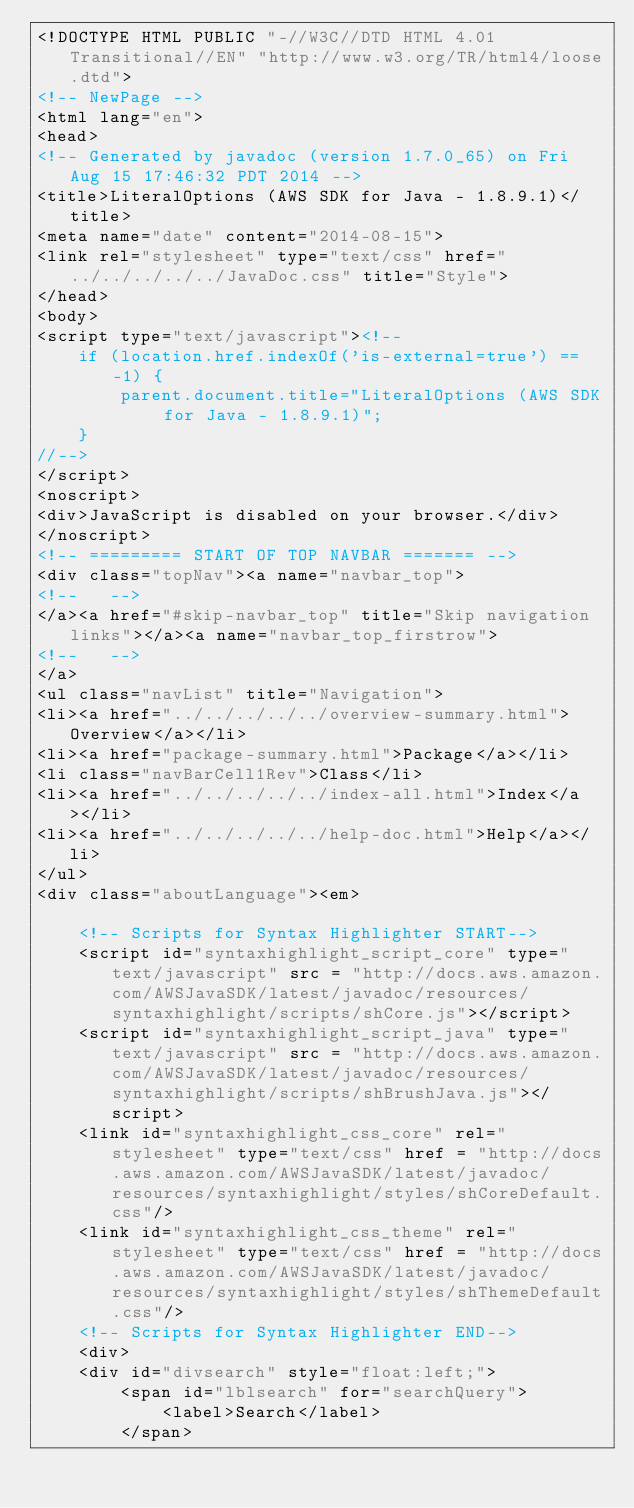Convert code to text. <code><loc_0><loc_0><loc_500><loc_500><_HTML_><!DOCTYPE HTML PUBLIC "-//W3C//DTD HTML 4.01 Transitional//EN" "http://www.w3.org/TR/html4/loose.dtd">
<!-- NewPage -->
<html lang="en">
<head>
<!-- Generated by javadoc (version 1.7.0_65) on Fri Aug 15 17:46:32 PDT 2014 -->
<title>LiteralOptions (AWS SDK for Java - 1.8.9.1)</title>
<meta name="date" content="2014-08-15">
<link rel="stylesheet" type="text/css" href="../../../../../JavaDoc.css" title="Style">
</head>
<body>
<script type="text/javascript"><!--
    if (location.href.indexOf('is-external=true') == -1) {
        parent.document.title="LiteralOptions (AWS SDK for Java - 1.8.9.1)";
    }
//-->
</script>
<noscript>
<div>JavaScript is disabled on your browser.</div>
</noscript>
<!-- ========= START OF TOP NAVBAR ======= -->
<div class="topNav"><a name="navbar_top">
<!--   -->
</a><a href="#skip-navbar_top" title="Skip navigation links"></a><a name="navbar_top_firstrow">
<!--   -->
</a>
<ul class="navList" title="Navigation">
<li><a href="../../../../../overview-summary.html">Overview</a></li>
<li><a href="package-summary.html">Package</a></li>
<li class="navBarCell1Rev">Class</li>
<li><a href="../../../../../index-all.html">Index</a></li>
<li><a href="../../../../../help-doc.html">Help</a></li>
</ul>
<div class="aboutLanguage"><em>

    <!-- Scripts for Syntax Highlighter START-->
    <script id="syntaxhighlight_script_core" type="text/javascript" src = "http://docs.aws.amazon.com/AWSJavaSDK/latest/javadoc/resources/syntaxhighlight/scripts/shCore.js"></script>
    <script id="syntaxhighlight_script_java" type="text/javascript" src = "http://docs.aws.amazon.com/AWSJavaSDK/latest/javadoc/resources/syntaxhighlight/scripts/shBrushJava.js"></script>
    <link id="syntaxhighlight_css_core" rel="stylesheet" type="text/css" href = "http://docs.aws.amazon.com/AWSJavaSDK/latest/javadoc/resources/syntaxhighlight/styles/shCoreDefault.css"/>
    <link id="syntaxhighlight_css_theme" rel="stylesheet" type="text/css" href = "http://docs.aws.amazon.com/AWSJavaSDK/latest/javadoc/resources/syntaxhighlight/styles/shThemeDefault.css"/>
    <!-- Scripts for Syntax Highlighter END-->
    <div>
    <div id="divsearch" style="float:left;">
        <span id="lblsearch" for="searchQuery">
            <label>Search</label>
        </span>
</code> 